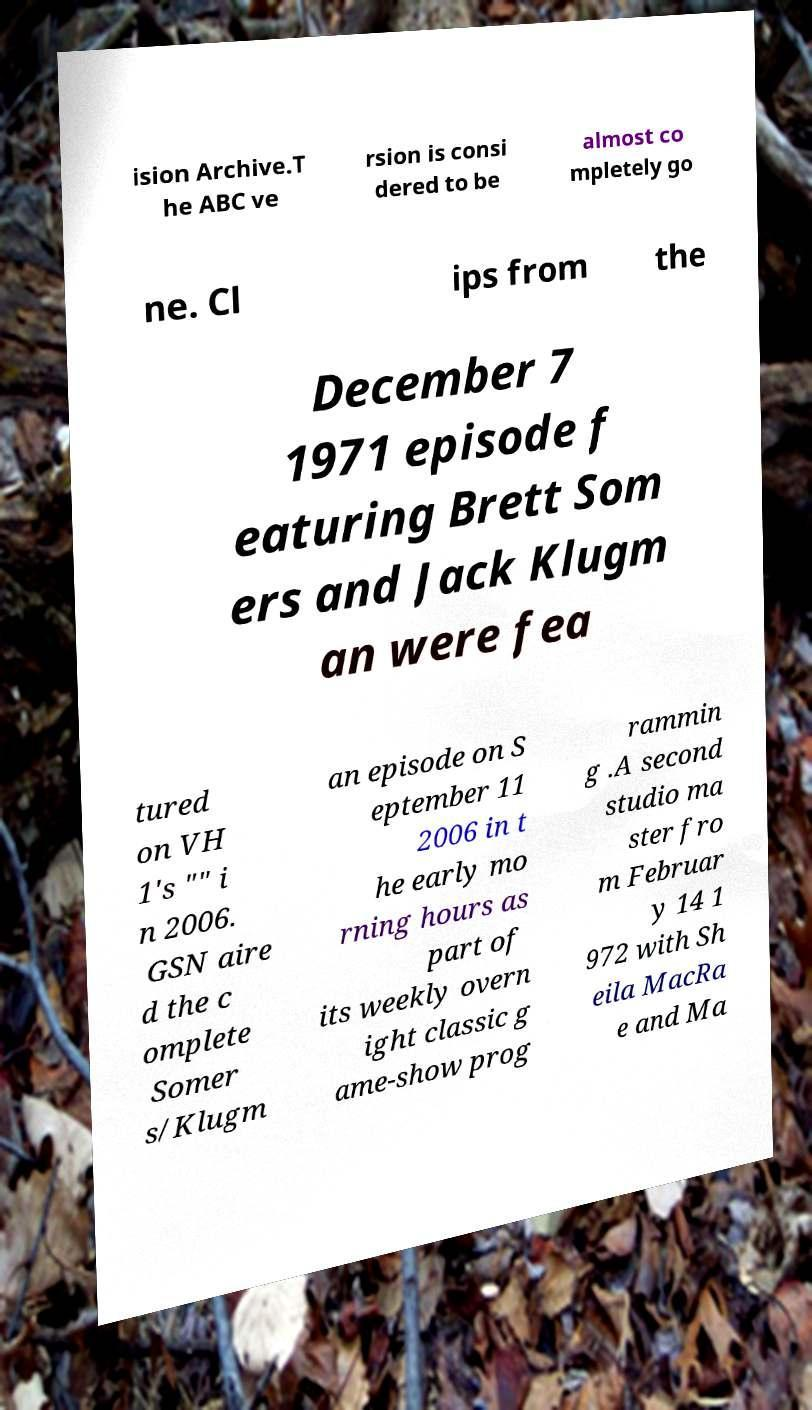There's text embedded in this image that I need extracted. Can you transcribe it verbatim? ision Archive.T he ABC ve rsion is consi dered to be almost co mpletely go ne. Cl ips from the December 7 1971 episode f eaturing Brett Som ers and Jack Klugm an were fea tured on VH 1's "" i n 2006. GSN aire d the c omplete Somer s/Klugm an episode on S eptember 11 2006 in t he early mo rning hours as part of its weekly overn ight classic g ame-show prog rammin g .A second studio ma ster fro m Februar y 14 1 972 with Sh eila MacRa e and Ma 